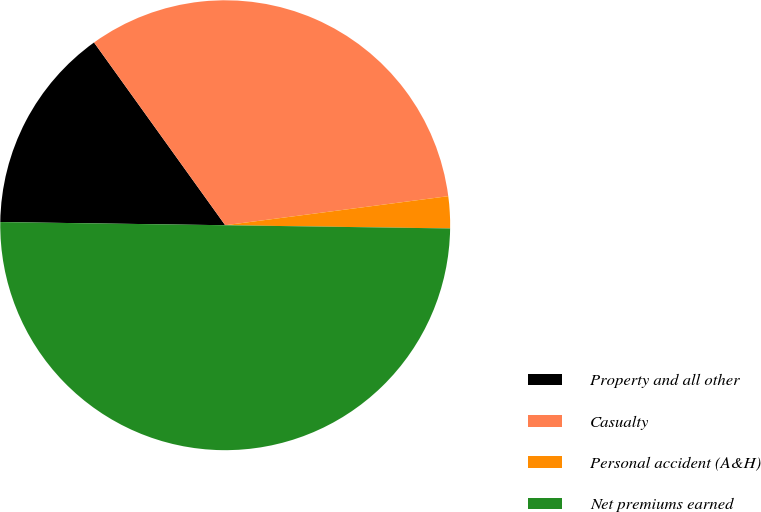Convert chart. <chart><loc_0><loc_0><loc_500><loc_500><pie_chart><fcel>Property and all other<fcel>Casualty<fcel>Personal accident (A&H)<fcel>Net premiums earned<nl><fcel>14.87%<fcel>32.85%<fcel>2.29%<fcel>50.0%<nl></chart> 